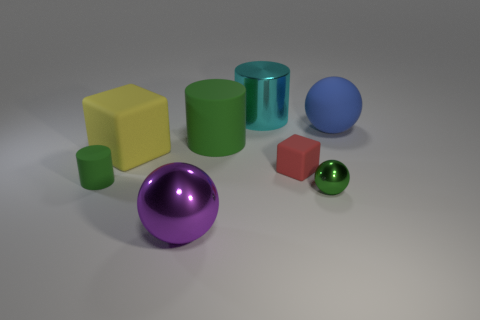What color is the object that is both in front of the tiny matte block and to the right of the large purple thing? green 